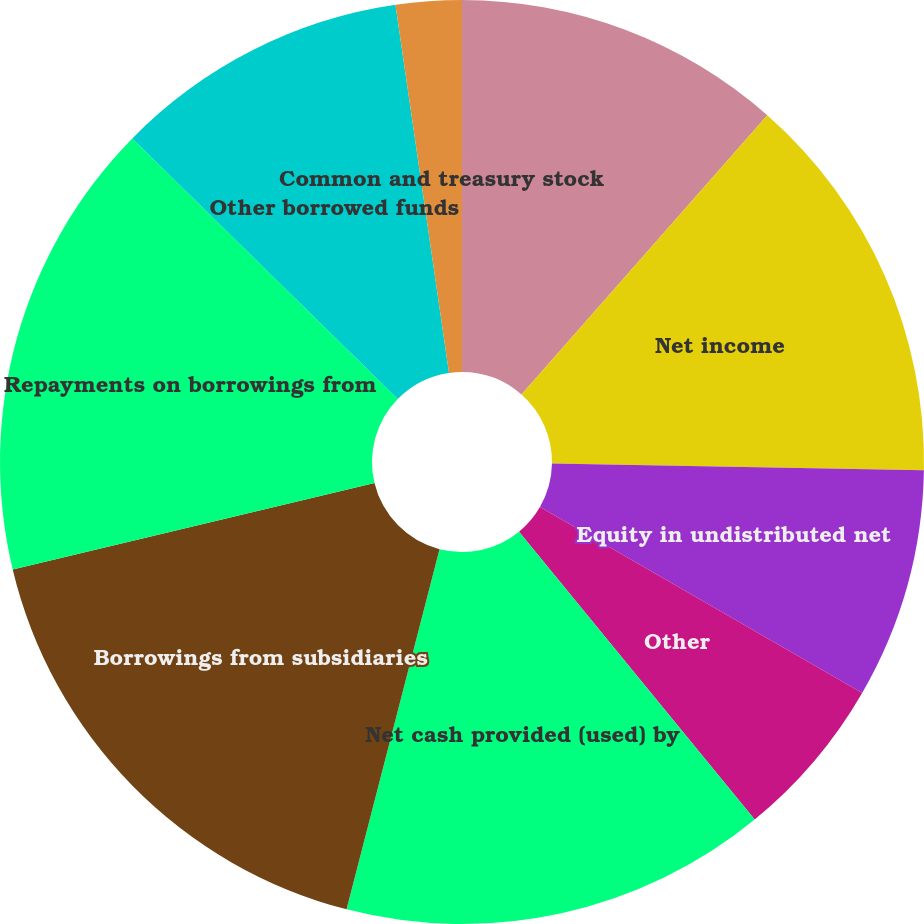<chart> <loc_0><loc_0><loc_500><loc_500><pie_chart><fcel>Year ended December 31 - in<fcel>Net income<fcel>Equity in undistributed net<fcel>Other<fcel>Net cash provided (used) by<fcel>Borrowings from subsidiaries<fcel>Repayments on borrowings from<fcel>Other borrowed funds<fcel>Common and treasury stock<nl><fcel>11.49%<fcel>13.79%<fcel>8.05%<fcel>5.75%<fcel>14.94%<fcel>17.24%<fcel>16.09%<fcel>10.35%<fcel>2.3%<nl></chart> 